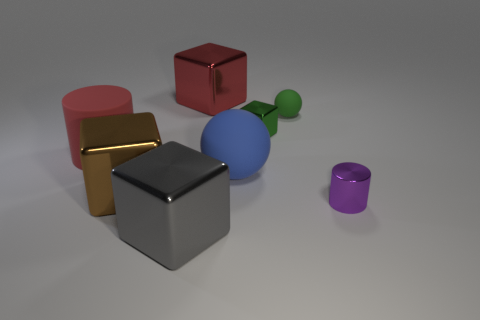Subtract 1 cubes. How many cubes are left? 3 Add 2 purple metallic cylinders. How many objects exist? 10 Subtract all gray cubes. How many cubes are left? 3 Subtract all gray blocks. How many blocks are left? 3 Subtract 1 green spheres. How many objects are left? 7 Subtract all red cubes. Subtract all blue cylinders. How many cubes are left? 3 Subtract all cyan cylinders. How many brown spheres are left? 0 Subtract all gray blocks. Subtract all large red blocks. How many objects are left? 6 Add 3 small green spheres. How many small green spheres are left? 4 Add 4 small green metal blocks. How many small green metal blocks exist? 5 